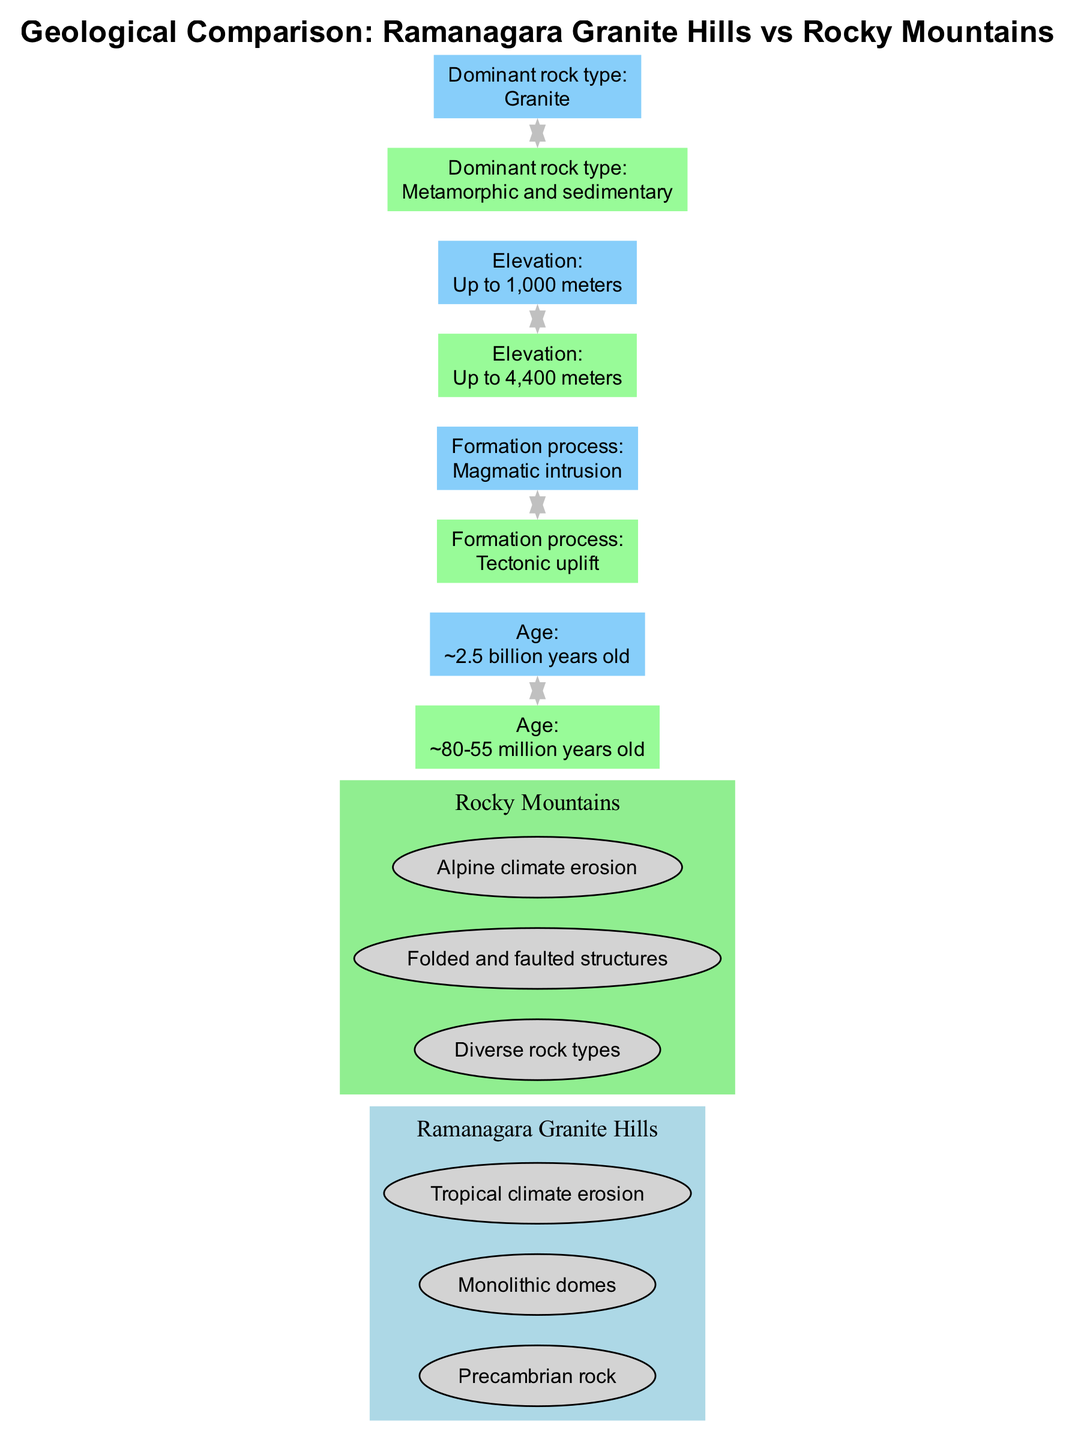What is the dominant rock type in Ramanagara Granite Hills? The diagram clearly states the dominant rock type for Ramanagara as "Granite." This information is directly obtained from the comparison point regarding the dominant rock type.
Answer: Granite What is the elevation of the Rocky Mountains? From the comparison point about elevation, it is indicated that the maximum elevation of the Rocky Mountains reaches "Up to 4,400 meters." This proves that Rocky Mountains are significantly higher in elevation as compared to Ramanagara.
Answer: Up to 4,400 meters What is the formation process of the Rocky Mountains? The diagram specifies that the formation process of the Rocky Mountains is described as "Tectonic uplift." This is detailed in the comparison point that discusses the formation process.
Answer: Tectonic uplift Which geological formation is older, Ramanagara Granite Hills or Rocky Mountains? The age comparison point indicates that Ramanagara Granite Hills is approximately "2.5 billion years old," while the Rocky Mountains are around "80-55 million years old." Thus, Ramanagara Granite Hills is the older geological formation.
Answer: Ramanagara Granite Hills What are the climate erosion types influencing the geological formations? The diagram lists "Tropical climate erosion" for Ramanagara Granite Hills and "Alpine climate erosion" for the Rocky Mountains. By referring to each formation's features, both climate types have influence on their respective erosions.
Answer: Tropical climate erosion, Alpine climate erosion What is the age difference between Ramanagara Granite Hills and Rocky Mountains? From the ages specified, Ramanagara is roughly "2.5 billion years" and Rocky Mountains are "80-55 million years." Calculating the difference shows the age difference is about "2.42 to 2.5 billion years."
Answer: About 2.42 to 2.5 billion years What type of climate erosion is associated with Ramanagara? The diagram clearly states that Ramanagara Granite Hills experience "Tropical climate erosion." This is specifically mentioned in the features section for Ramanagara.
Answer: Tropical climate erosion How do the formation processes differ between these two geological formations? The comparison point indicates that Ramanagara's process is "Magmatic intrusion," while the Rocky Mountains' process is "Tectonic uplift." The difference shows that they are formed through distinct geological processes.
Answer: Magmatic intrusion, Tectonic uplift 